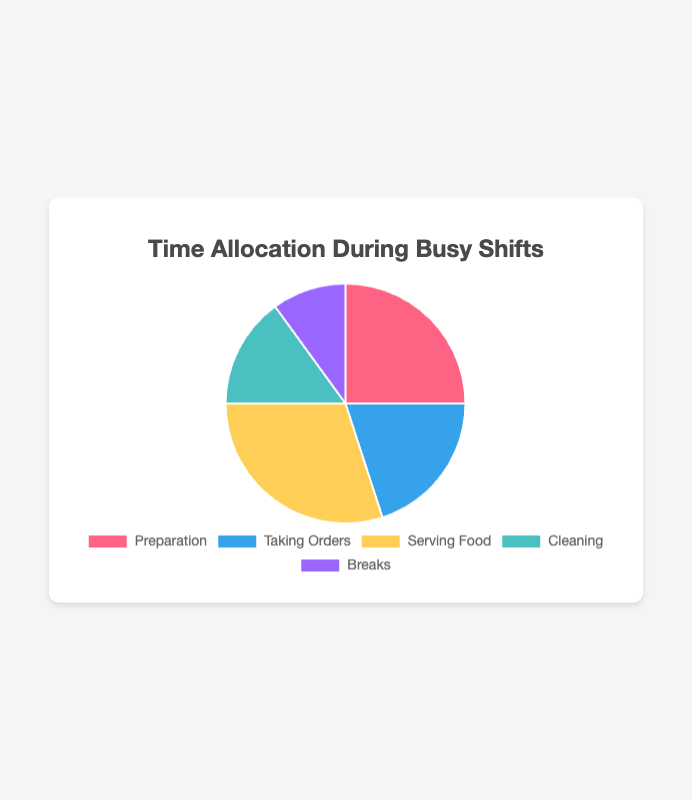What is the percentage of time allocated to Serving Food? The figure shows a pie chart with the different allocations of time. By looking at the segment labeled "Serving Food," we see that it accounts for 30% of the total time.
Answer: 30% Which activity takes up the least amount of time? The pie chart shows the allocation percentages for each activity, and "Breaks" has the smallest slice, indicating 10% of the total time.
Answer: Breaks Which two activities combined take up half of the total time? The combined percentage of "Preparation" (25%) and "Serving Food" (30%) is 55%, which is more than half. Therefore, we need to check other combinations. "Serving Food" (30%) and "Taking Orders" (20%) together make 50%, which is half.
Answer: Serving Food and Taking Orders Compare the time allocated to Cleaning and Breaks. Is Cleaning allocated more time? The pie chart shows that Cleaning is allocated 15%, whereas Breaks are allocated 10%. Hence, Cleaning is allocated more time.
Answer: Yes What is the total time spent on non-service activities (Preparation, Cleaning, Breaks)? Preparation takes 25%, Cleaning takes 15%, and Breaks take 10%. Adding these gives 25% + 15% + 10% = 50%.
Answer: 50% Which activity has a share greater than 20% but less than 30%? Looking at the pie chart, "Taking Orders" is allocated 20%, and "Preparation" is allocated 25%. Since 25% falls between 20% and 30%, "Preparation" is the activity that meets the criteria.
Answer: Preparation If we combine the time spent on Taking Orders and Cleaning, what percentage do they occupy? Taking Orders accounts for 20%, and Cleaning makes up 15%. Their combined percentage is 20% + 15% = 35%.
Answer: 35% What is the difference in time allocation between Serving Food and Preparation? Serving Food is allocated 30% and Preparation is allocated 25%. The difference between these two percentages is 30% - 25% = 5%.
Answer: 5% How does the time spent on Breaks visually compare to the other activities in the chart? In the pie chart, the slice representing Breaks is the smallest segment, indicating that it takes up the least amount of time (10%) compared to the other activities.
Answer: Breaks take up the least space Explain which activity pair equates to the time spent on Serving Food. Serving Food takes 30% of the time. Looking for two activities that sum up to 30%, we find that Preparation (25%) and Breaks (10%) collectively sum to 35%, not 30%. However, Taking Orders (20%) and Cleaning (15%) equal 35%. There isn’t a pair that exactly equals Serving Food, but Preparation (25%) and Breaks (10%) add up closest to 30%. Combining two activities not found that exactly adds to 30%.
Answer: No exact pair found 